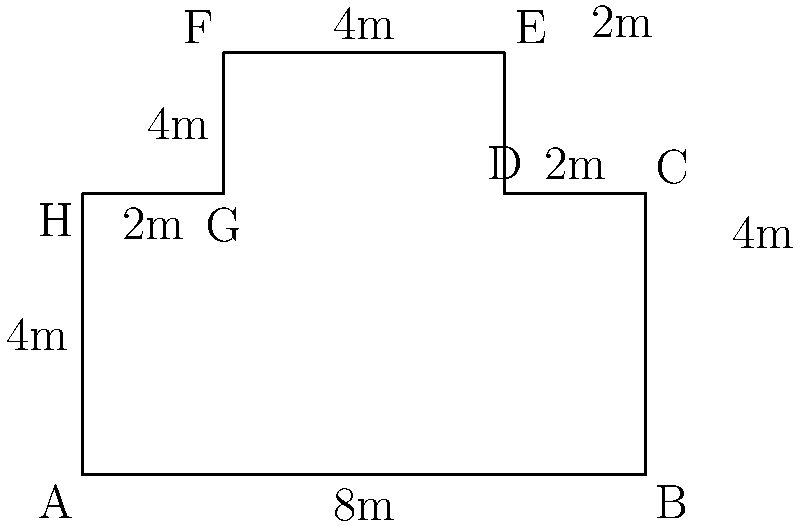A megachurch's floor plan is represented by the complex polygonal shape shown above. If each unit in the diagram represents 1 meter, what is the perimeter of this floor plan in meters? To calculate the perimeter of the megachurch floor plan, we need to sum up the lengths of all sides:

1. Side AB: $8$ meters
2. Side BC: $4$ meters
3. Side CD: $2$ meters
4. Side DE: $2$ meters
5. Side EF: $4$ meters
6. Side FG: $4$ meters
7. Side GH: $2$ meters
8. Side HA: $4$ meters

Total perimeter = $8 + 4 + 2 + 2 + 4 + 4 + 2 + 4 = 30$ meters

Therefore, the perimeter of the megachurch floor plan is 30 meters.
Answer: $30$ meters 